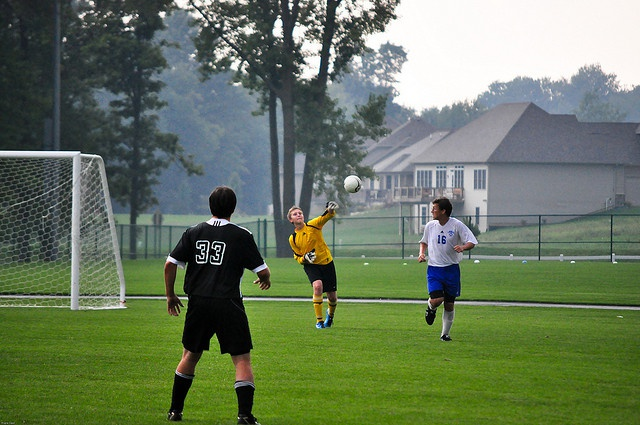Describe the objects in this image and their specific colors. I can see people in black, gray, olive, and darkgreen tones, people in black, darkgray, gray, and navy tones, people in black, olive, and orange tones, and sports ball in black, lightgray, darkgray, and gray tones in this image. 